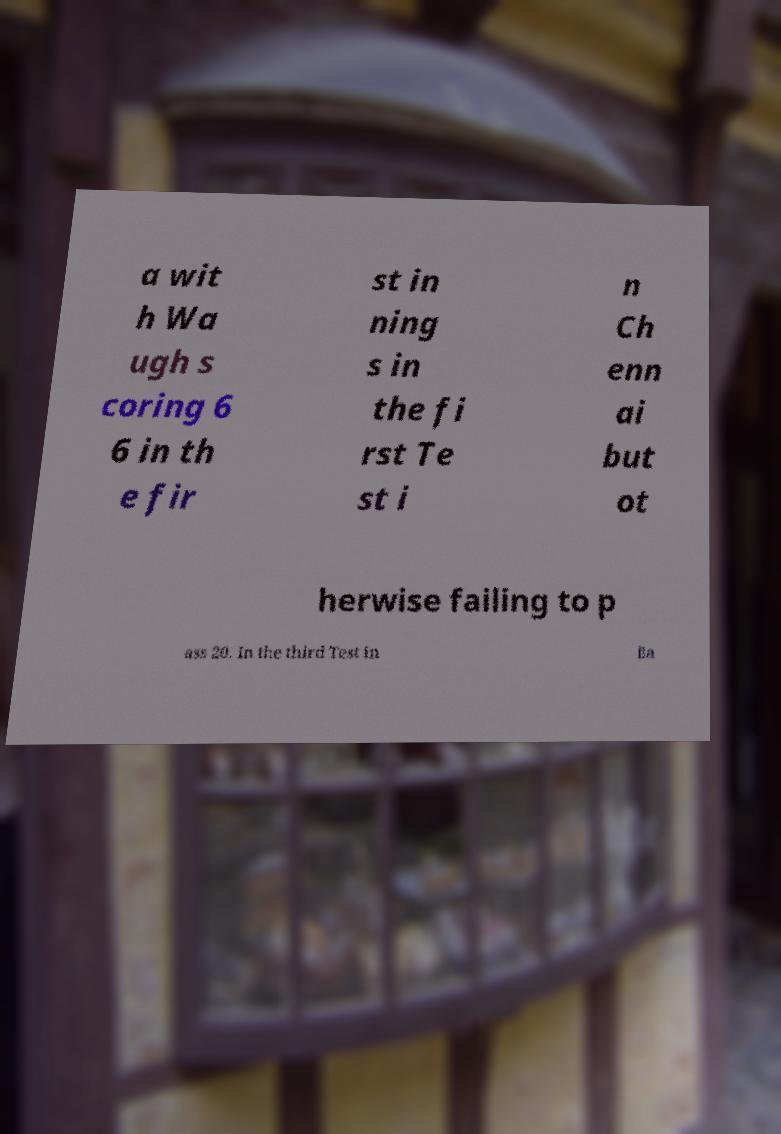For documentation purposes, I need the text within this image transcribed. Could you provide that? a wit h Wa ugh s coring 6 6 in th e fir st in ning s in the fi rst Te st i n Ch enn ai but ot herwise failing to p ass 20. In the third Test in Ba 